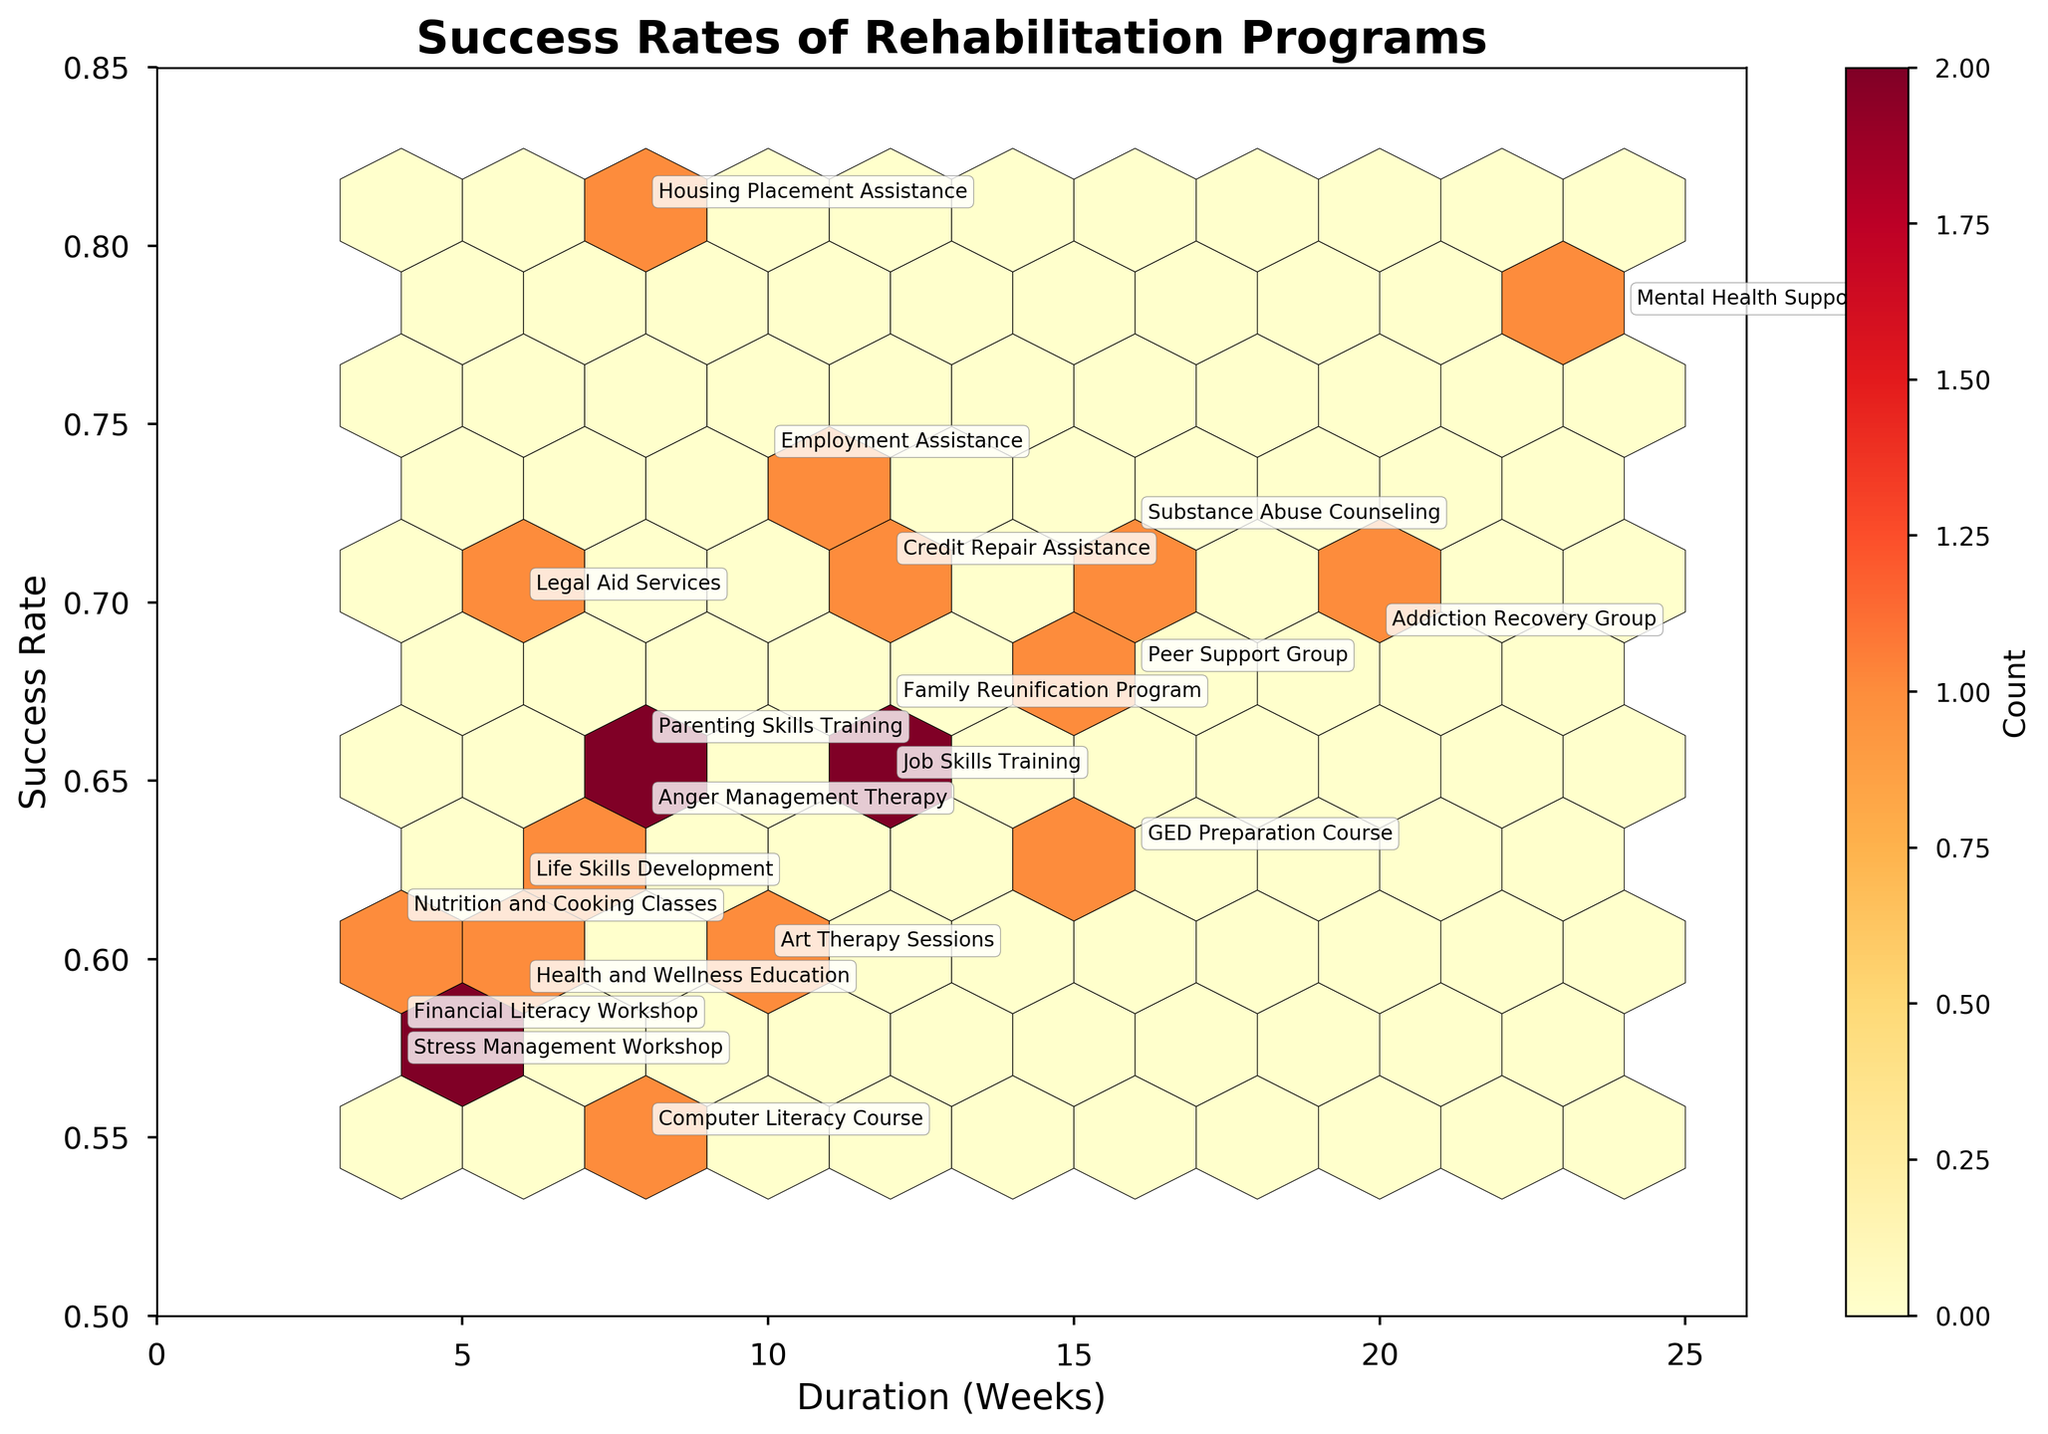How many intervention types are shown in the figure? By looking at the plot, we can see that there are different colors representing different intervention types. We count the unique intervention types that are each annotated with different program names.
Answer: 5 What is the title of the figure? The title is located at the top of the plot.
Answer: Success Rates of Rehabilitation Programs What is the program with the highest success rate, and what is its rate? By observing the vertical location of the points, the highest point represents the highest success rate. The annotated program at this point is Housing Placement Assistance.
Answer: Housing Placement Assistance, 0.81 Which program has the shortest duration and what is its duration? The left-most point on the horizontal axis represents the shortest duration. The annotated program at this point is Financial Literacy Workshop.
Answer: Financial Literacy Workshop, 4 weeks Which Therapeutic program has the highest success rate? Locate all points annotated with Therapeutic programs and find the one positioned highest on the vertical axis. Mental Health Support is the highest.
Answer: Mental Health Support How many programs have a success rate higher than 0.70? Count the number of points above the 0.70 mark on the vertical axis.
Answer: 7 What is the median success rate for Educational programs? Find all annotated points for Educational programs and list their success rates, then calculate the median of these values. The values are 0.58, 0.62, 0.55, 0.59, 0.61, 0.63, and 0.66. The median is the middle value when the rates are ordered.
Answer: 0.61 Which program has the longest duration among the ones with a success rate below 0.60, and what is its duration? Find all points below the 0.60 rate line and look for the longest point horizontally. Specifically, it is Art Therapy Sessions.
Answer: Art Therapy Sessions, 10 weeks How does the success rate of Employment Assistance compare to Legal Aid Services? Locate the points annotated with these programs and observe their vertical positions. Employment Assistance has a higher success rate.
Answer: Employment Assistance is higher What is the average success rate for programs lasting 8 weeks? Find all points with a duration of 8 weeks and list their success rates, then calculate the average. The values are 0.81, 0.55, 0.64, 0.66, and 0.70. The average is (0.81 + 0.55 + 0.64 + 0.66 + 0.70) / 5 = 0.672.
Answer: 0.672 